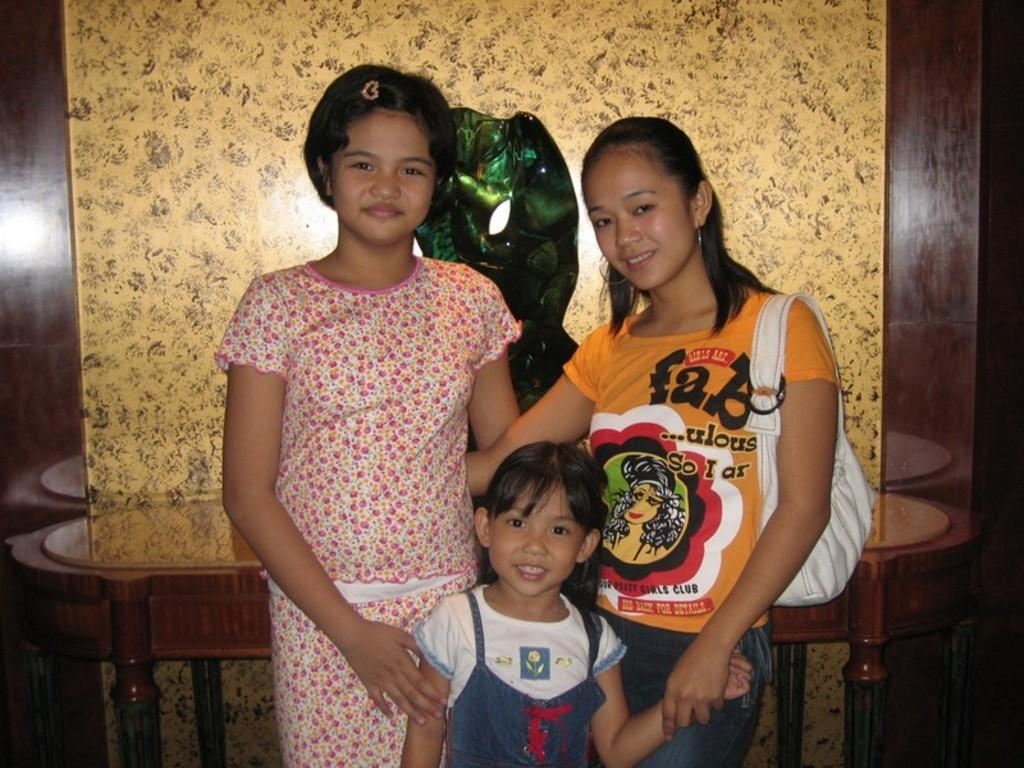How many girls are present in the image? There are three girls in the image. What is one of the girls holding? One of the girls is holding a bag. What can be seen in the background of the image? There is a wall in the background of the image. What type of furniture is visible in the image? There is a table in the image. Can you describe any other objects present in the image? There is at least one other object in the image, but its specific nature is not mentioned in the provided facts. What type of plough is being used by the girl in the image? There is no plough present in the image; it features three girls and a table. How does the nerve affect the behavior of the girls in the image? There is no mention of a nerve or any behavioral effects in the image. 